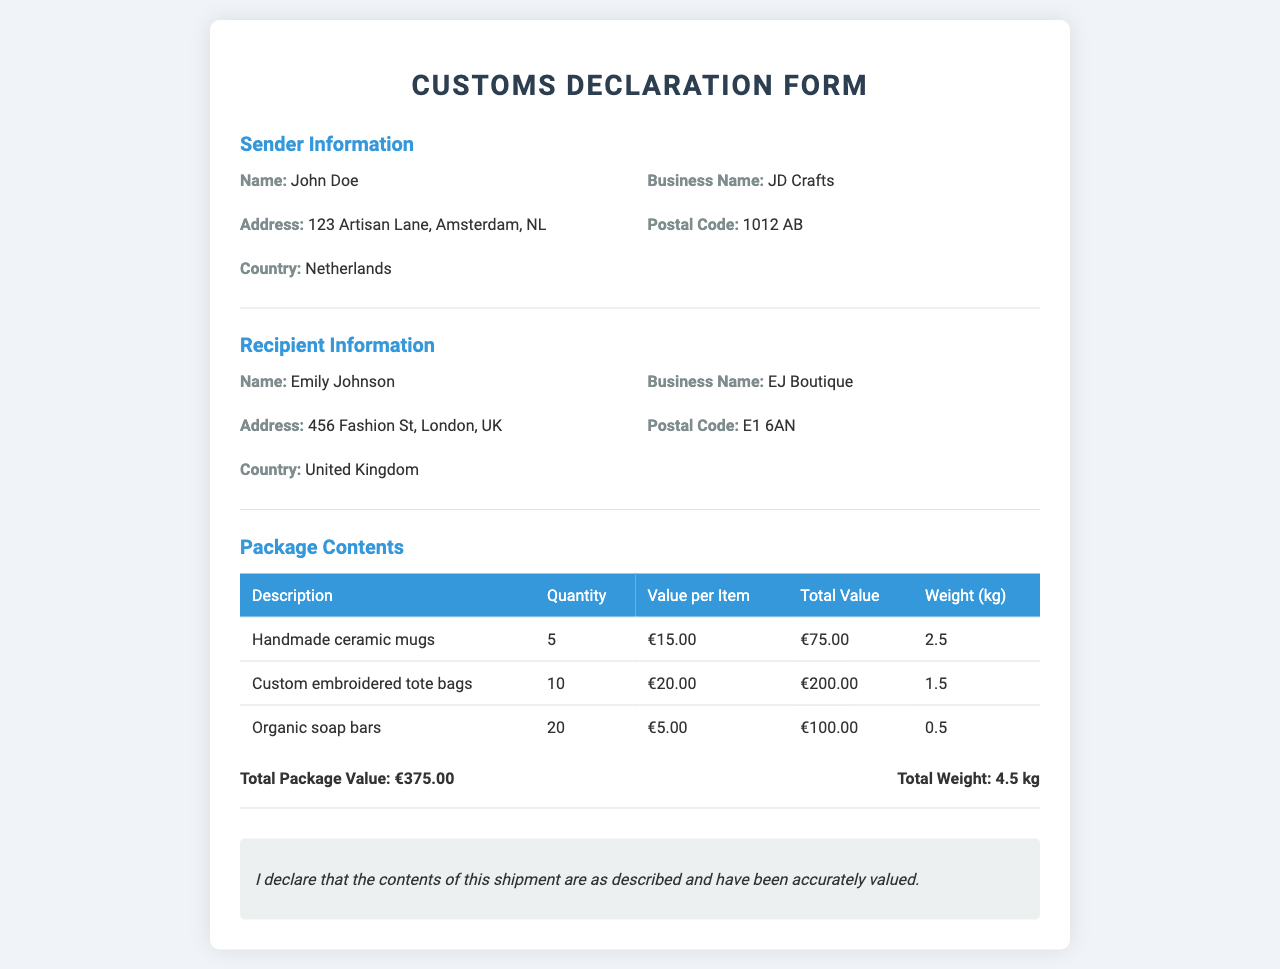What is the sender's name? The sender's name is mentioned in the "Sender Information" section of the document.
Answer: John Doe What is the total package value? The total package value is calculated by summing the individual total values of all items in the "Package Contents" section.
Answer: €375.00 What is the recipient's country? The recipient's country is listed in the "Recipient Information" section of the document.
Answer: United Kingdom How many handmade ceramic mugs are included? The quantity of handmade ceramic mugs is specified in the "Package Contents" table.
Answer: 5 What is the total weight of the package? The total weight is provided in the "Package Contents" section after all items' weights are summed.
Answer: 4.5 kg What is the value per custom embroidered tote bag? The value for each custom embroidered tote bag is found in the "Package Contents" table.
Answer: €20.00 What is the recipient's name? The recipient's name is listed in the "Recipient Information" section.
Answer: Emily Johnson What type of items are included in this shipment? The items are detailed in the "Package Contents" section under descriptions.
Answer: Handmade ceramic mugs, custom embroidered tote bags, organic soap bars What declaration statement is provided? The declaration statement is included at the end of the document, indicating what the sender asserts about the package contents.
Answer: I declare that the contents of this shipment are as described and have been accurately valued 